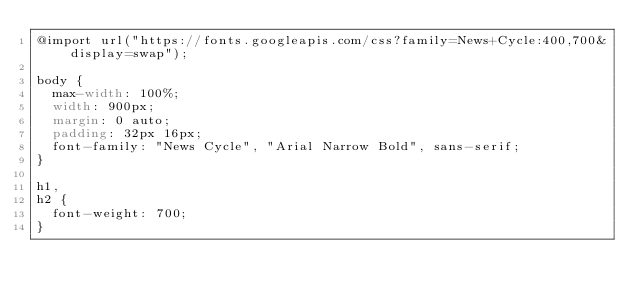Convert code to text. <code><loc_0><loc_0><loc_500><loc_500><_CSS_>@import url("https://fonts.googleapis.com/css?family=News+Cycle:400,700&display=swap");

body {
  max-width: 100%;
  width: 900px;
  margin: 0 auto;
  padding: 32px 16px;
  font-family: "News Cycle", "Arial Narrow Bold", sans-serif;
}

h1,
h2 {
  font-weight: 700;
}
</code> 